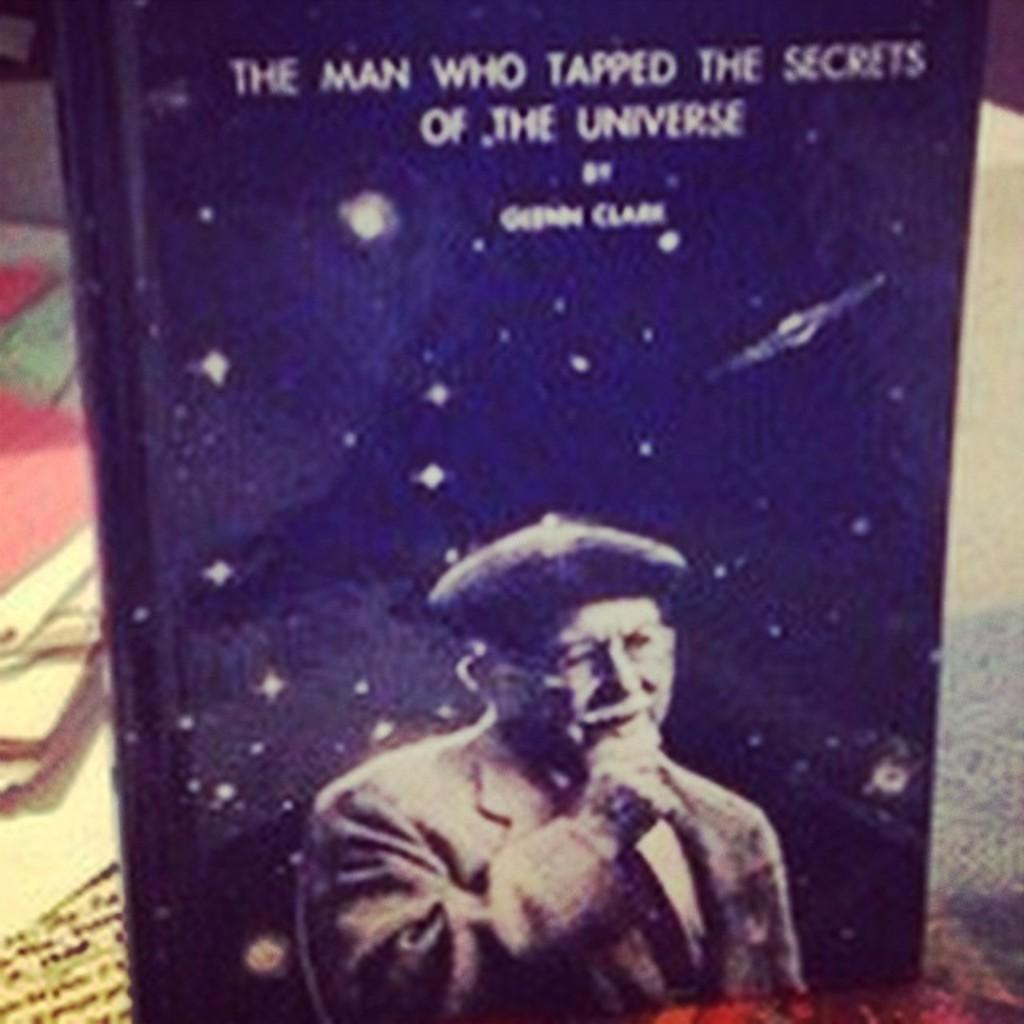<image>
Offer a succinct explanation of the picture presented. The Man Who Tapped the Secrets of the Universe was written by Glenn Clark. 